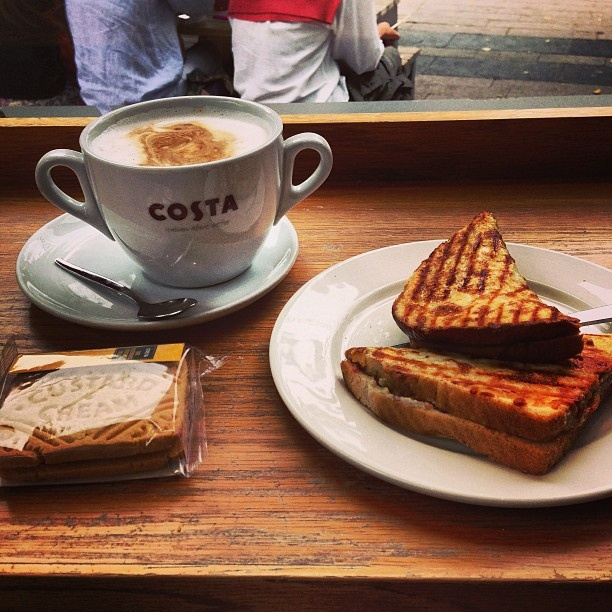Describe the objects in this image and their specific colors. I can see dining table in black, maroon, tan, and brown tones, cup in black, gray, and lightgray tones, sandwich in black, maroon, and brown tones, people in black, lightgray, darkgray, and gray tones, and pizza in black, orange, brown, and maroon tones in this image. 